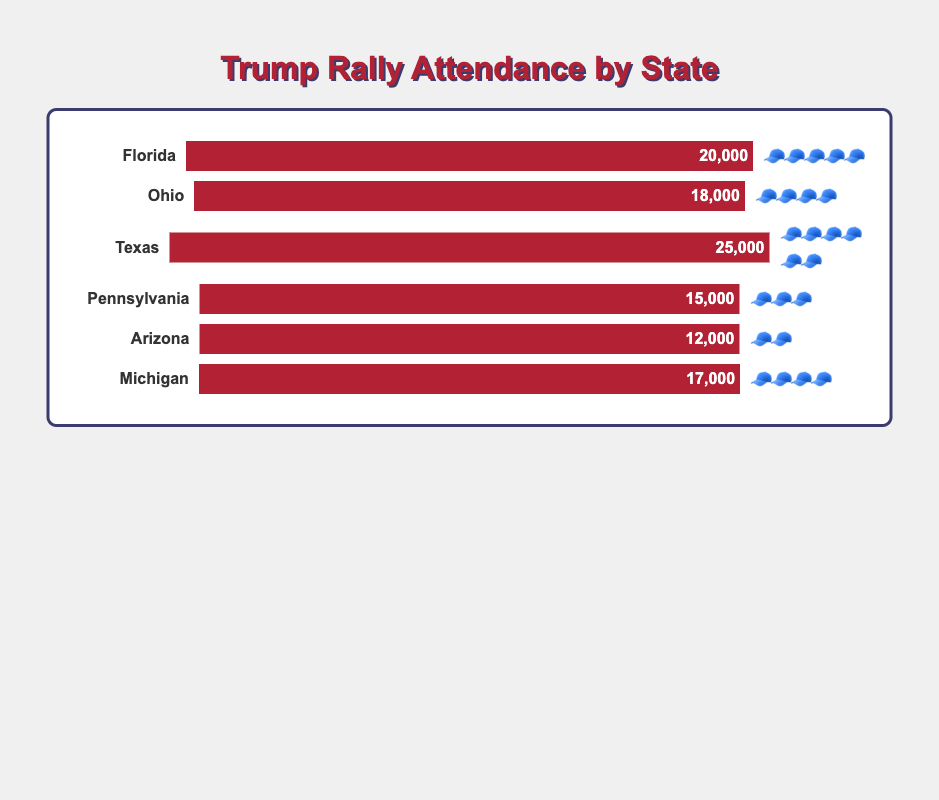What state has the highest rally attendance? By looking at the figure, we see that Texas has the highest bar, indicating the highest attendance. The attendance figure for Texas is 25,000.
Answer: Texas How many 🧢 emojis does Ohio have? Glancing at the figure, Ohio's row contains four 🧢 emojis.
Answer: 4 Which state has a lower attendance than Michigan but more magas than Arizona? Comparing the bars, Florida and Ohio have more attendance than Arizona but are lower than Michigan. Florida has more magas than Arizona.
Answer: Florida What is the total attendance for all states combined? Summing the attendance numbers: 20,000 (Florida) + 18,000 (Ohio) + 25,000 (Texas) + 15,000 (Pennsylvania) + 12,000 (Arizona) + 17,000 (Michigan) = 107,000.
Answer: 107,000 Which state has both the least number of magas and the least attendance? By comparing the rows, Arizona has the least number of emojis (2) and the lowest attendance (12,000).
Answer: Arizona Which two states have the same number of magas, and what is their attendance difference? Ohio and Michigan both have four 🧢 emojis. Ohio's attendance is 18,000, and Michigan's is 17,000. Their attendance difference is 18,000 - 17,000 = 1,000.
Answer: Ohio and Michigan, 1,000 What is the average attendance of the states with three or more magas? States with at least three 🧢 emojis are Florida, Ohio, Texas, Pennsylvania, and Michigan. Adding their attendance numbers: 20,000 (Florida) + 18,000 (Ohio) + 25,000 (Texas) + 15,000 (Pennsylvania) + 17,000 (Michigan) = 95,000. There are 5 states, so the average is 95,000 / 5 = 19,000.
Answer: 19,000 How many states are represented in the chart? Each bar represents a state, and there are six bars.
Answer: 6 